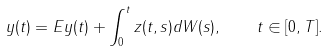Convert formula to latex. <formula><loc_0><loc_0><loc_500><loc_500>y ( t ) = E y ( t ) + \int _ { 0 } ^ { t } z ( t , s ) d W ( s ) , \quad t \in [ 0 , T ] .</formula> 